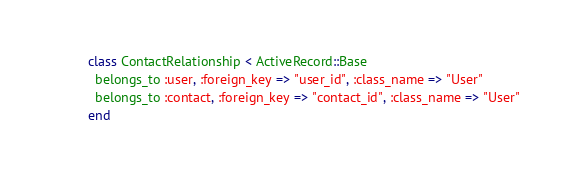Convert code to text. <code><loc_0><loc_0><loc_500><loc_500><_Ruby_>class ContactRelationship < ActiveRecord::Base
  belongs_to :user, :foreign_key => "user_id", :class_name => "User"
  belongs_to :contact, :foreign_key => "contact_id", :class_name => "User"
end
</code> 